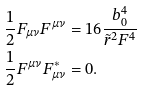Convert formula to latex. <formula><loc_0><loc_0><loc_500><loc_500>\frac { 1 } { 2 } F _ { \mu \nu } F ^ { \mu \nu } & = 1 6 \frac { b _ { 0 } ^ { 4 } } { \tilde { r } ^ { 2 } F ^ { 4 } } \\ \frac { 1 } { 2 } F ^ { \mu \nu } F _ { \mu \nu } ^ { \ast } & = 0 .</formula> 